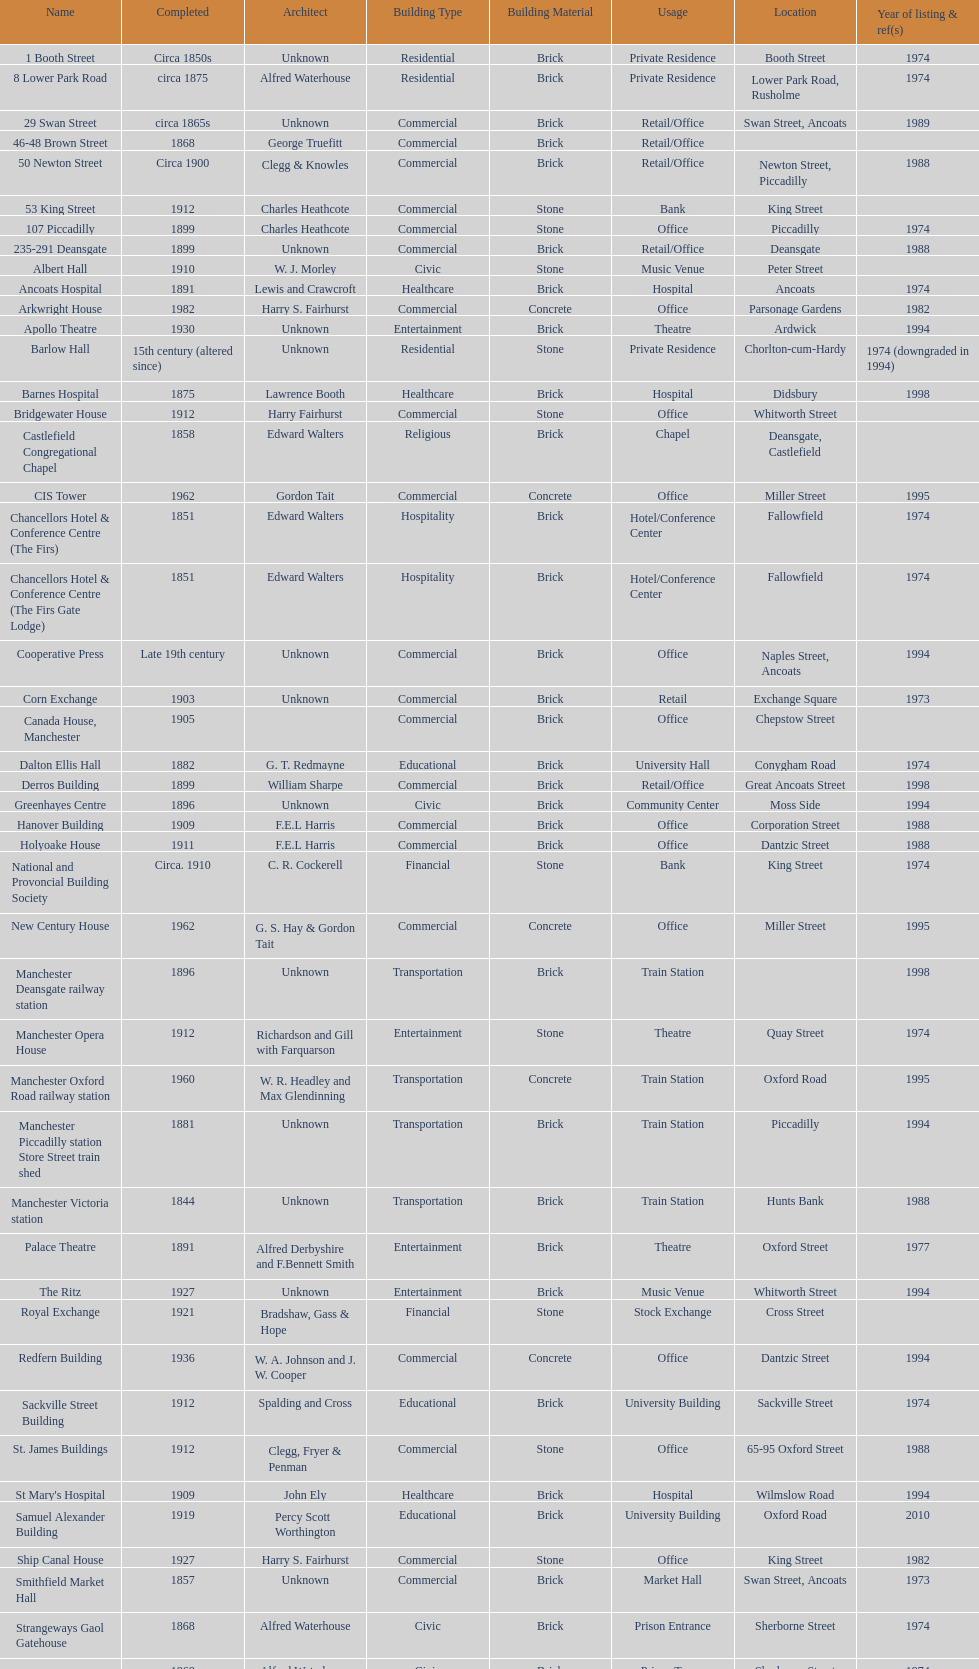I'm looking to parse the entire table for insights. Could you assist me with that? {'header': ['Name', 'Completed', 'Architect', 'Building Type', 'Building Material', 'Usage', 'Location', 'Year of listing & ref(s)'], 'rows': [['1 Booth Street', 'Circa 1850s', 'Unknown', 'Residential', 'Brick', 'Private Residence', 'Booth Street', '1974'], ['8 Lower Park Road', 'circa 1875', 'Alfred Waterhouse', 'Residential', 'Brick', 'Private Residence', 'Lower Park Road, Rusholme', '1974'], ['29 Swan Street', 'circa 1865s', 'Unknown', 'Commercial', 'Brick', 'Retail/Office', 'Swan Street, Ancoats', '1989'], ['46-48 Brown Street', '1868', 'George Truefitt', 'Commercial', 'Brick', 'Retail/Office', '', ''], ['50 Newton Street', 'Circa 1900', 'Clegg & Knowles', 'Commercial', 'Brick', 'Retail/Office', 'Newton Street, Piccadilly', '1988'], ['53 King Street', '1912', 'Charles Heathcote', 'Commercial', 'Stone', 'Bank', 'King Street', ''], ['107 Piccadilly', '1899', 'Charles Heathcote', 'Commercial', 'Stone', 'Office', 'Piccadilly', '1974'], ['235-291 Deansgate', '1899', 'Unknown', 'Commercial', 'Brick', 'Retail/Office', 'Deansgate', '1988'], ['Albert Hall', '1910', 'W. J. Morley', 'Civic', 'Stone', 'Music Venue', 'Peter Street', ''], ['Ancoats Hospital', '1891', 'Lewis and Crawcroft', 'Healthcare', 'Brick', 'Hospital', 'Ancoats', '1974'], ['Arkwright House', '1982', 'Harry S. Fairhurst', 'Commercial', 'Concrete', 'Office', 'Parsonage Gardens', '1982'], ['Apollo Theatre', '1930', 'Unknown', 'Entertainment', 'Brick', 'Theatre', 'Ardwick', '1994'], ['Barlow Hall', '15th century (altered since)', 'Unknown', 'Residential', 'Stone', 'Private Residence', 'Chorlton-cum-Hardy', '1974 (downgraded in 1994)'], ['Barnes Hospital', '1875', 'Lawrence Booth', 'Healthcare', 'Brick', 'Hospital', 'Didsbury', '1998'], ['Bridgewater House', '1912', 'Harry Fairhurst', 'Commercial', 'Stone', 'Office', 'Whitworth Street', ''], ['Castlefield Congregational Chapel', '1858', 'Edward Walters', 'Religious', 'Brick', 'Chapel', 'Deansgate, Castlefield', ''], ['CIS Tower', '1962', 'Gordon Tait', 'Commercial', 'Concrete', 'Office', 'Miller Street', '1995'], ['Chancellors Hotel & Conference Centre (The Firs)', '1851', 'Edward Walters', 'Hospitality', 'Brick', 'Hotel/Conference Center', 'Fallowfield', '1974'], ['Chancellors Hotel & Conference Centre (The Firs Gate Lodge)', '1851', 'Edward Walters', 'Hospitality', 'Brick', 'Hotel/Conference Center', 'Fallowfield', '1974'], ['Cooperative Press', 'Late 19th century', 'Unknown', 'Commercial', 'Brick', 'Office', 'Naples Street, Ancoats', '1994'], ['Corn Exchange', '1903', 'Unknown', 'Commercial', 'Brick', 'Retail', 'Exchange Square', '1973'], ['Canada House, Manchester', '1905', '', 'Commercial', 'Brick', 'Office', 'Chepstow Street', ''], ['Dalton Ellis Hall', '1882', 'G. T. Redmayne', 'Educational', 'Brick', 'University Hall', 'Conygham Road', '1974'], ['Derros Building', '1899', 'William Sharpe', 'Commercial', 'Brick', 'Retail/Office', 'Great Ancoats Street', '1998'], ['Greenhayes Centre', '1896', 'Unknown', 'Civic', 'Brick', 'Community Center', 'Moss Side', '1994'], ['Hanover Building', '1909', 'F.E.L Harris', 'Commercial', 'Brick', 'Office', 'Corporation Street', '1988'], ['Holyoake House', '1911', 'F.E.L Harris', 'Commercial', 'Brick', 'Office', 'Dantzic Street', '1988'], ['National and Provoncial Building Society', 'Circa. 1910', 'C. R. Cockerell', 'Financial', 'Stone', 'Bank', 'King Street', '1974'], ['New Century House', '1962', 'G. S. Hay & Gordon Tait', 'Commercial', 'Concrete', 'Office', 'Miller Street', '1995'], ['Manchester Deansgate railway station', '1896', 'Unknown', 'Transportation', 'Brick', 'Train Station', '', '1998'], ['Manchester Opera House', '1912', 'Richardson and Gill with Farquarson', 'Entertainment', 'Stone', 'Theatre', 'Quay Street', '1974'], ['Manchester Oxford Road railway station', '1960', 'W. R. Headley and Max Glendinning', 'Transportation', 'Concrete', 'Train Station', 'Oxford Road', '1995'], ['Manchester Piccadilly station Store Street train shed', '1881', 'Unknown', 'Transportation', 'Brick', 'Train Station', 'Piccadilly', '1994'], ['Manchester Victoria station', '1844', 'Unknown', 'Transportation', 'Brick', 'Train Station', 'Hunts Bank', '1988'], ['Palace Theatre', '1891', 'Alfred Derbyshire and F.Bennett Smith', 'Entertainment', 'Brick', 'Theatre', 'Oxford Street', '1977'], ['The Ritz', '1927', 'Unknown', 'Entertainment', 'Brick', 'Music Venue', 'Whitworth Street', '1994'], ['Royal Exchange', '1921', 'Bradshaw, Gass & Hope', 'Financial', 'Stone', 'Stock Exchange', 'Cross Street', ''], ['Redfern Building', '1936', 'W. A. Johnson and J. W. Cooper', 'Commercial', 'Concrete', 'Office', 'Dantzic Street', '1994'], ['Sackville Street Building', '1912', 'Spalding and Cross', 'Educational', 'Brick', 'University Building', 'Sackville Street', '1974'], ['St. James Buildings', '1912', 'Clegg, Fryer & Penman', 'Commercial', 'Stone', 'Office', '65-95 Oxford Street', '1988'], ["St Mary's Hospital", '1909', 'John Ely', 'Healthcare', 'Brick', 'Hospital', 'Wilmslow Road', '1994'], ['Samuel Alexander Building', '1919', 'Percy Scott Worthington', 'Educational', 'Brick', 'University Building', 'Oxford Road', '2010'], ['Ship Canal House', '1927', 'Harry S. Fairhurst', 'Commercial', 'Stone', 'Office', 'King Street', '1982'], ['Smithfield Market Hall', '1857', 'Unknown', 'Commercial', 'Brick', 'Market Hall', 'Swan Street, Ancoats', '1973'], ['Strangeways Gaol Gatehouse', '1868', 'Alfred Waterhouse', 'Civic', 'Brick', 'Prison Entrance', 'Sherborne Street', '1974'], ['Strangeways Prison ventilation and watch tower', '1868', 'Alfred Waterhouse', 'Civic', 'Brick', 'Prison Tower', 'Sherborne Street', '1974'], ['Theatre Royal', '1845', 'Irwin and Chester', 'Entertainment', 'Stone', 'Theatre', 'Peter Street', '1974'], ['Toast Rack', '1960', 'L. C. Howitt', 'Educational', 'Concrete', 'University Building', 'Fallowfield', '1999'], ['The Old Wellington Inn', 'Mid-16th century', 'Unknown', 'Hospitality', 'Timber', 'Pub', 'Shambles Square', '1952'], ['Whitworth Park Mansions', 'Circa 1840s', 'Unknown', 'Residential', 'Brick', 'Private Residence', 'Whitworth Park', '1974']]} How many names are listed with an image? 39. 